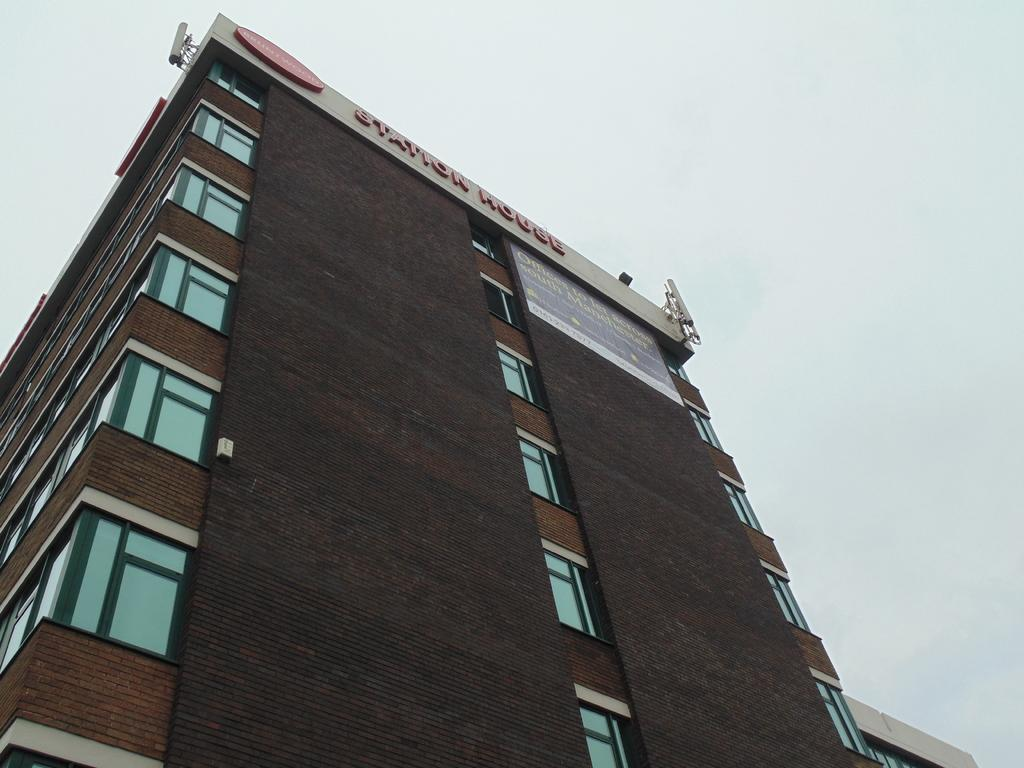What is the main subject in the foreground of the image? There is a building in the foreground of the image. What can be seen in the background of the image? The sky is visible in the background of the image. What type of argument is the lawyer having with the plough in the image? There is no lawyer, plough, or argument present in the image. 